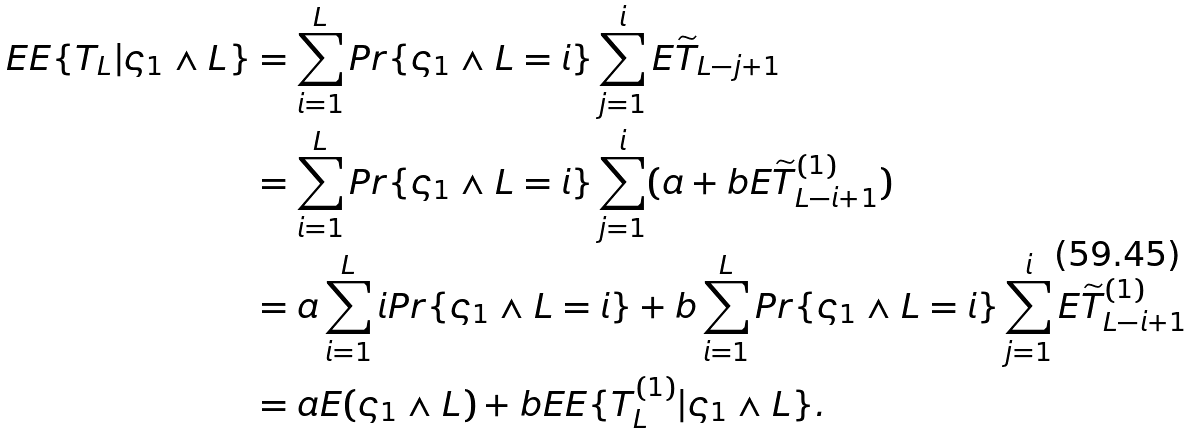<formula> <loc_0><loc_0><loc_500><loc_500>E E \{ T _ { L } | \varsigma _ { 1 } \wedge L \} & = \sum _ { i = 1 } ^ { L } P r \{ \varsigma _ { 1 } \wedge L = i \} \sum _ { j = 1 } ^ { i } E \widetilde { T } _ { L - j + 1 } \\ & = \sum _ { i = 1 } ^ { L } P r \{ \varsigma _ { 1 } \wedge L = i \} \sum _ { j = 1 } ^ { i } ( a + b E \widetilde { T } _ { L - i + 1 } ^ { ( 1 ) } ) \\ & = a \sum _ { i = 1 } ^ { L } i P r \{ \varsigma _ { 1 } \wedge L = i \} + b \sum _ { i = 1 } ^ { L } P r \{ \varsigma _ { 1 } \wedge L = i \} \sum _ { j = 1 } ^ { i } E \widetilde { T } _ { L - i + 1 } ^ { ( 1 ) } \\ & = a E ( \varsigma _ { 1 } \wedge L ) + b E E \{ T _ { L } ^ { ( 1 ) } | \varsigma _ { 1 } \wedge L \} .</formula> 